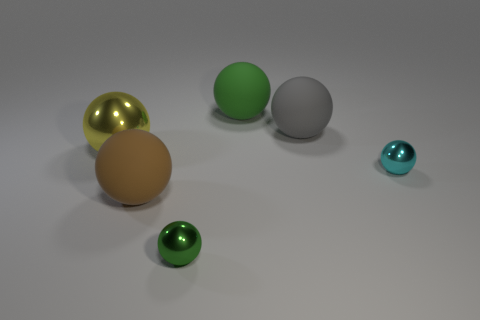There is another tiny shiny object that is the same shape as the cyan object; what color is it?
Keep it short and to the point. Green. Do the large green object and the rubber thing that is on the right side of the big green object have the same shape?
Your answer should be very brief. Yes. How many things are either rubber spheres behind the yellow ball or objects that are on the left side of the green metallic thing?
Your answer should be very brief. 4. What is the large brown thing made of?
Your response must be concise. Rubber. How many other things are there of the same size as the green metal object?
Keep it short and to the point. 1. There is a green object behind the large yellow metallic sphere; what size is it?
Your answer should be very brief. Large. What is the material of the tiny thing that is in front of the tiny shiny sphere behind the metallic sphere that is in front of the small cyan thing?
Offer a very short reply. Metal. Is the tiny cyan object the same shape as the big gray matte thing?
Offer a terse response. Yes. What number of shiny objects are either large green balls or yellow things?
Your response must be concise. 1. How many big purple rubber spheres are there?
Your response must be concise. 0. 